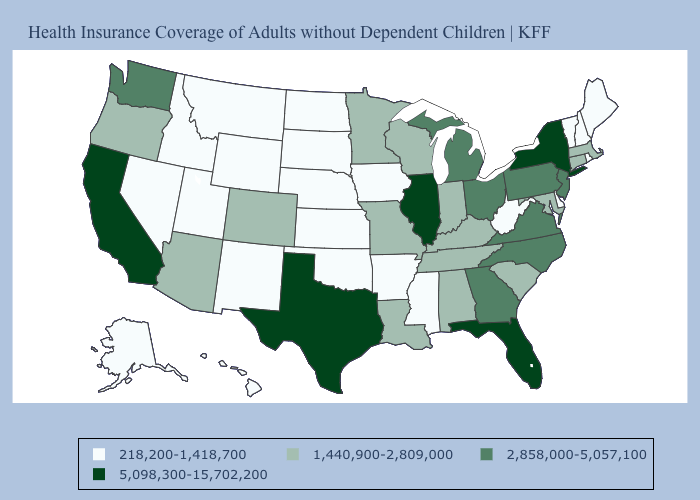Which states have the lowest value in the USA?
Short answer required. Alaska, Arkansas, Delaware, Hawaii, Idaho, Iowa, Kansas, Maine, Mississippi, Montana, Nebraska, Nevada, New Hampshire, New Mexico, North Dakota, Oklahoma, Rhode Island, South Dakota, Utah, Vermont, West Virginia, Wyoming. Name the states that have a value in the range 1,440,900-2,809,000?
Short answer required. Alabama, Arizona, Colorado, Connecticut, Indiana, Kentucky, Louisiana, Maryland, Massachusetts, Minnesota, Missouri, Oregon, South Carolina, Tennessee, Wisconsin. Name the states that have a value in the range 1,440,900-2,809,000?
Be succinct. Alabama, Arizona, Colorado, Connecticut, Indiana, Kentucky, Louisiana, Maryland, Massachusetts, Minnesota, Missouri, Oregon, South Carolina, Tennessee, Wisconsin. Name the states that have a value in the range 5,098,300-15,702,200?
Be succinct. California, Florida, Illinois, New York, Texas. What is the value of Montana?
Short answer required. 218,200-1,418,700. Which states have the lowest value in the West?
Answer briefly. Alaska, Hawaii, Idaho, Montana, Nevada, New Mexico, Utah, Wyoming. What is the lowest value in the South?
Give a very brief answer. 218,200-1,418,700. What is the lowest value in the USA?
Write a very short answer. 218,200-1,418,700. What is the lowest value in the USA?
Quick response, please. 218,200-1,418,700. Does Texas have the highest value in the South?
Be succinct. Yes. Name the states that have a value in the range 5,098,300-15,702,200?
Be succinct. California, Florida, Illinois, New York, Texas. Among the states that border Mississippi , which have the lowest value?
Answer briefly. Arkansas. Name the states that have a value in the range 1,440,900-2,809,000?
Be succinct. Alabama, Arizona, Colorado, Connecticut, Indiana, Kentucky, Louisiana, Maryland, Massachusetts, Minnesota, Missouri, Oregon, South Carolina, Tennessee, Wisconsin. What is the value of Utah?
Keep it brief. 218,200-1,418,700. Does the first symbol in the legend represent the smallest category?
Quick response, please. Yes. 